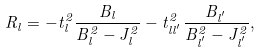Convert formula to latex. <formula><loc_0><loc_0><loc_500><loc_500>R _ { l } = - t ^ { 2 } _ { l } \frac { B _ { l } } { B _ { l } ^ { 2 } - J ^ { 2 } _ { l } } - t ^ { 2 } _ { l l ^ { ^ { \prime } } } \frac { B _ { l ^ { ^ { \prime } } } } { B _ { l ^ { ^ { \prime } } } ^ { 2 } - J ^ { 2 } _ { l ^ { ^ { \prime } } } } ,</formula> 